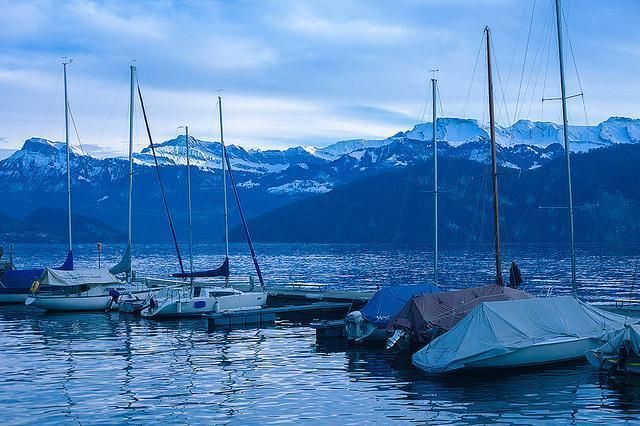How many boats are in the picture?
Give a very brief answer. 6. How many blue truck cabs are there?
Give a very brief answer. 0. 